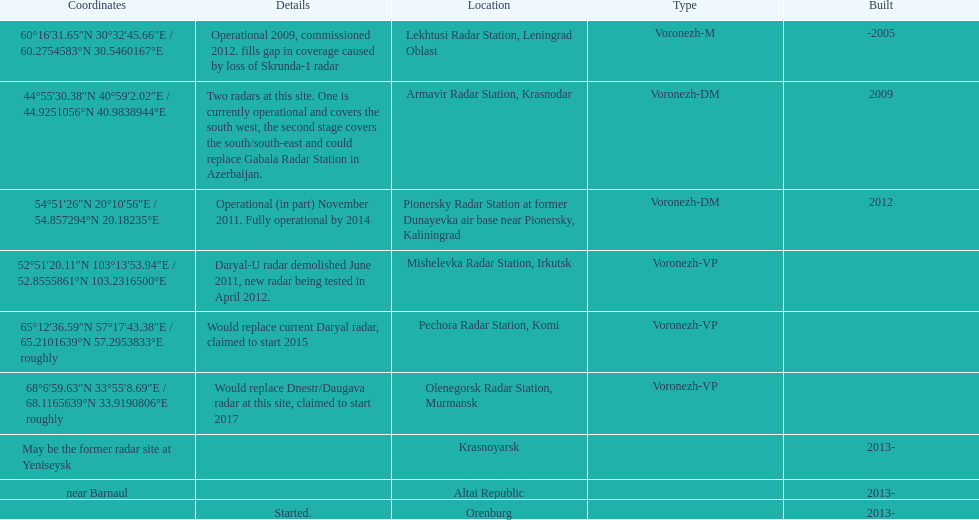What is the only radar that will start in 2015? Pechora Radar Station, Komi. 